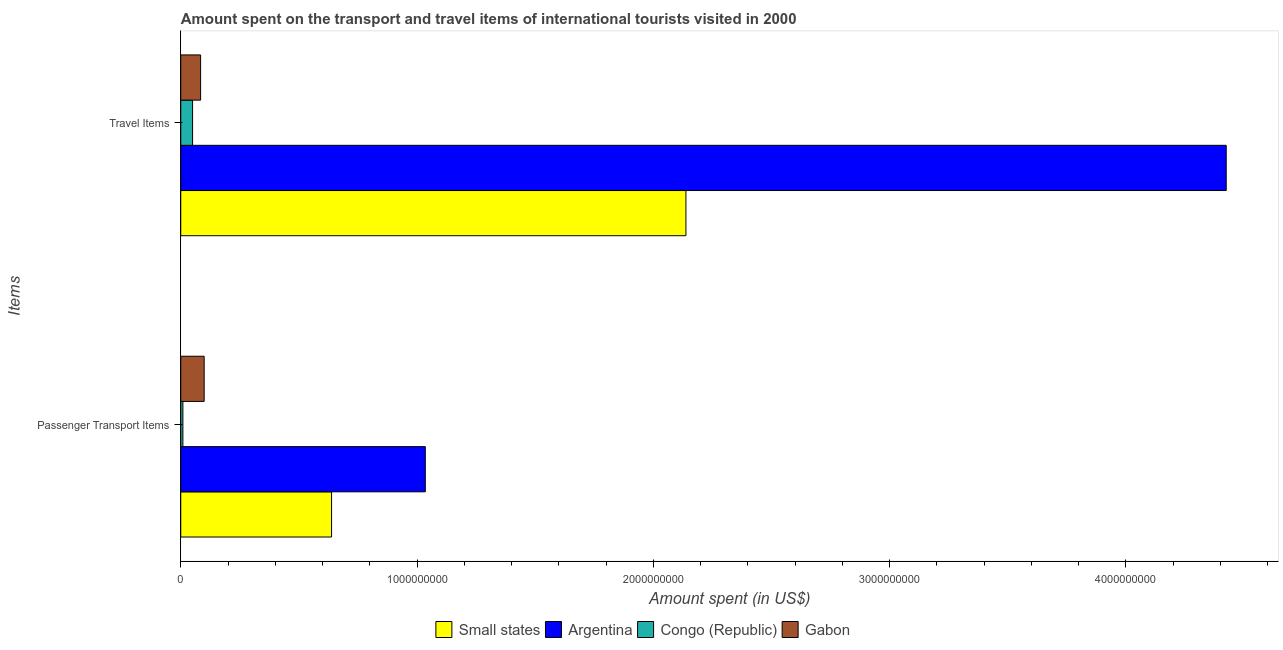Are the number of bars per tick equal to the number of legend labels?
Make the answer very short. Yes. How many bars are there on the 1st tick from the bottom?
Offer a terse response. 4. What is the label of the 2nd group of bars from the top?
Your answer should be very brief. Passenger Transport Items. What is the amount spent in travel items in Gabon?
Your response must be concise. 8.40e+07. Across all countries, what is the maximum amount spent in travel items?
Your response must be concise. 4.42e+09. Across all countries, what is the minimum amount spent on passenger transport items?
Provide a succinct answer. 9.00e+06. In which country was the amount spent on passenger transport items maximum?
Your answer should be very brief. Argentina. In which country was the amount spent on passenger transport items minimum?
Provide a succinct answer. Congo (Republic). What is the total amount spent in travel items in the graph?
Your response must be concise. 6.70e+09. What is the difference between the amount spent in travel items in Small states and that in Argentina?
Offer a terse response. -2.29e+09. What is the difference between the amount spent in travel items in Gabon and the amount spent on passenger transport items in Small states?
Offer a terse response. -5.54e+08. What is the average amount spent in travel items per country?
Provide a succinct answer. 1.67e+09. What is the difference between the amount spent in travel items and amount spent on passenger transport items in Small states?
Make the answer very short. 1.50e+09. In how many countries, is the amount spent on passenger transport items greater than 200000000 US$?
Make the answer very short. 2. What is the ratio of the amount spent on passenger transport items in Small states to that in Gabon?
Keep it short and to the point. 6.45. Is the amount spent on passenger transport items in Argentina less than that in Small states?
Ensure brevity in your answer.  No. In how many countries, is the amount spent in travel items greater than the average amount spent in travel items taken over all countries?
Keep it short and to the point. 2. What does the 3rd bar from the top in Travel Items represents?
Give a very brief answer. Argentina. What does the 3rd bar from the bottom in Passenger Transport Items represents?
Provide a short and direct response. Congo (Republic). Are all the bars in the graph horizontal?
Make the answer very short. Yes. What is the difference between two consecutive major ticks on the X-axis?
Offer a very short reply. 1.00e+09. Does the graph contain any zero values?
Make the answer very short. No. How many legend labels are there?
Make the answer very short. 4. What is the title of the graph?
Provide a succinct answer. Amount spent on the transport and travel items of international tourists visited in 2000. Does "Luxembourg" appear as one of the legend labels in the graph?
Give a very brief answer. No. What is the label or title of the X-axis?
Make the answer very short. Amount spent (in US$). What is the label or title of the Y-axis?
Ensure brevity in your answer.  Items. What is the Amount spent (in US$) in Small states in Passenger Transport Items?
Ensure brevity in your answer.  6.38e+08. What is the Amount spent (in US$) of Argentina in Passenger Transport Items?
Provide a short and direct response. 1.04e+09. What is the Amount spent (in US$) of Congo (Republic) in Passenger Transport Items?
Ensure brevity in your answer.  9.00e+06. What is the Amount spent (in US$) in Gabon in Passenger Transport Items?
Give a very brief answer. 9.90e+07. What is the Amount spent (in US$) in Small states in Travel Items?
Your answer should be very brief. 2.14e+09. What is the Amount spent (in US$) in Argentina in Travel Items?
Give a very brief answer. 4.42e+09. What is the Amount spent (in US$) of Gabon in Travel Items?
Offer a terse response. 8.40e+07. Across all Items, what is the maximum Amount spent (in US$) in Small states?
Make the answer very short. 2.14e+09. Across all Items, what is the maximum Amount spent (in US$) in Argentina?
Make the answer very short. 4.42e+09. Across all Items, what is the maximum Amount spent (in US$) of Gabon?
Provide a succinct answer. 9.90e+07. Across all Items, what is the minimum Amount spent (in US$) in Small states?
Offer a very short reply. 6.38e+08. Across all Items, what is the minimum Amount spent (in US$) of Argentina?
Give a very brief answer. 1.04e+09. Across all Items, what is the minimum Amount spent (in US$) in Congo (Republic)?
Provide a succinct answer. 9.00e+06. Across all Items, what is the minimum Amount spent (in US$) in Gabon?
Ensure brevity in your answer.  8.40e+07. What is the total Amount spent (in US$) of Small states in the graph?
Offer a very short reply. 2.78e+09. What is the total Amount spent (in US$) of Argentina in the graph?
Offer a terse response. 5.46e+09. What is the total Amount spent (in US$) of Congo (Republic) in the graph?
Your answer should be very brief. 5.90e+07. What is the total Amount spent (in US$) in Gabon in the graph?
Provide a short and direct response. 1.83e+08. What is the difference between the Amount spent (in US$) in Small states in Passenger Transport Items and that in Travel Items?
Provide a short and direct response. -1.50e+09. What is the difference between the Amount spent (in US$) of Argentina in Passenger Transport Items and that in Travel Items?
Your response must be concise. -3.39e+09. What is the difference between the Amount spent (in US$) in Congo (Republic) in Passenger Transport Items and that in Travel Items?
Keep it short and to the point. -4.10e+07. What is the difference between the Amount spent (in US$) in Gabon in Passenger Transport Items and that in Travel Items?
Your answer should be compact. 1.50e+07. What is the difference between the Amount spent (in US$) in Small states in Passenger Transport Items and the Amount spent (in US$) in Argentina in Travel Items?
Offer a very short reply. -3.79e+09. What is the difference between the Amount spent (in US$) in Small states in Passenger Transport Items and the Amount spent (in US$) in Congo (Republic) in Travel Items?
Offer a very short reply. 5.88e+08. What is the difference between the Amount spent (in US$) of Small states in Passenger Transport Items and the Amount spent (in US$) of Gabon in Travel Items?
Make the answer very short. 5.54e+08. What is the difference between the Amount spent (in US$) of Argentina in Passenger Transport Items and the Amount spent (in US$) of Congo (Republic) in Travel Items?
Your response must be concise. 9.85e+08. What is the difference between the Amount spent (in US$) of Argentina in Passenger Transport Items and the Amount spent (in US$) of Gabon in Travel Items?
Keep it short and to the point. 9.51e+08. What is the difference between the Amount spent (in US$) of Congo (Republic) in Passenger Transport Items and the Amount spent (in US$) of Gabon in Travel Items?
Ensure brevity in your answer.  -7.50e+07. What is the average Amount spent (in US$) in Small states per Items?
Your answer should be compact. 1.39e+09. What is the average Amount spent (in US$) in Argentina per Items?
Provide a succinct answer. 2.73e+09. What is the average Amount spent (in US$) in Congo (Republic) per Items?
Your answer should be compact. 2.95e+07. What is the average Amount spent (in US$) of Gabon per Items?
Give a very brief answer. 9.15e+07. What is the difference between the Amount spent (in US$) in Small states and Amount spent (in US$) in Argentina in Passenger Transport Items?
Your answer should be compact. -3.97e+08. What is the difference between the Amount spent (in US$) of Small states and Amount spent (in US$) of Congo (Republic) in Passenger Transport Items?
Your answer should be very brief. 6.29e+08. What is the difference between the Amount spent (in US$) of Small states and Amount spent (in US$) of Gabon in Passenger Transport Items?
Keep it short and to the point. 5.39e+08. What is the difference between the Amount spent (in US$) in Argentina and Amount spent (in US$) in Congo (Republic) in Passenger Transport Items?
Provide a succinct answer. 1.03e+09. What is the difference between the Amount spent (in US$) of Argentina and Amount spent (in US$) of Gabon in Passenger Transport Items?
Provide a short and direct response. 9.36e+08. What is the difference between the Amount spent (in US$) of Congo (Republic) and Amount spent (in US$) of Gabon in Passenger Transport Items?
Ensure brevity in your answer.  -9.00e+07. What is the difference between the Amount spent (in US$) of Small states and Amount spent (in US$) of Argentina in Travel Items?
Ensure brevity in your answer.  -2.29e+09. What is the difference between the Amount spent (in US$) in Small states and Amount spent (in US$) in Congo (Republic) in Travel Items?
Your answer should be compact. 2.09e+09. What is the difference between the Amount spent (in US$) in Small states and Amount spent (in US$) in Gabon in Travel Items?
Your response must be concise. 2.05e+09. What is the difference between the Amount spent (in US$) of Argentina and Amount spent (in US$) of Congo (Republic) in Travel Items?
Provide a short and direct response. 4.38e+09. What is the difference between the Amount spent (in US$) of Argentina and Amount spent (in US$) of Gabon in Travel Items?
Keep it short and to the point. 4.34e+09. What is the difference between the Amount spent (in US$) of Congo (Republic) and Amount spent (in US$) of Gabon in Travel Items?
Make the answer very short. -3.40e+07. What is the ratio of the Amount spent (in US$) in Small states in Passenger Transport Items to that in Travel Items?
Provide a succinct answer. 0.3. What is the ratio of the Amount spent (in US$) in Argentina in Passenger Transport Items to that in Travel Items?
Make the answer very short. 0.23. What is the ratio of the Amount spent (in US$) in Congo (Republic) in Passenger Transport Items to that in Travel Items?
Keep it short and to the point. 0.18. What is the ratio of the Amount spent (in US$) in Gabon in Passenger Transport Items to that in Travel Items?
Offer a terse response. 1.18. What is the difference between the highest and the second highest Amount spent (in US$) in Small states?
Your answer should be compact. 1.50e+09. What is the difference between the highest and the second highest Amount spent (in US$) of Argentina?
Ensure brevity in your answer.  3.39e+09. What is the difference between the highest and the second highest Amount spent (in US$) of Congo (Republic)?
Keep it short and to the point. 4.10e+07. What is the difference between the highest and the second highest Amount spent (in US$) in Gabon?
Your answer should be very brief. 1.50e+07. What is the difference between the highest and the lowest Amount spent (in US$) of Small states?
Keep it short and to the point. 1.50e+09. What is the difference between the highest and the lowest Amount spent (in US$) in Argentina?
Offer a very short reply. 3.39e+09. What is the difference between the highest and the lowest Amount spent (in US$) of Congo (Republic)?
Make the answer very short. 4.10e+07. What is the difference between the highest and the lowest Amount spent (in US$) of Gabon?
Offer a terse response. 1.50e+07. 